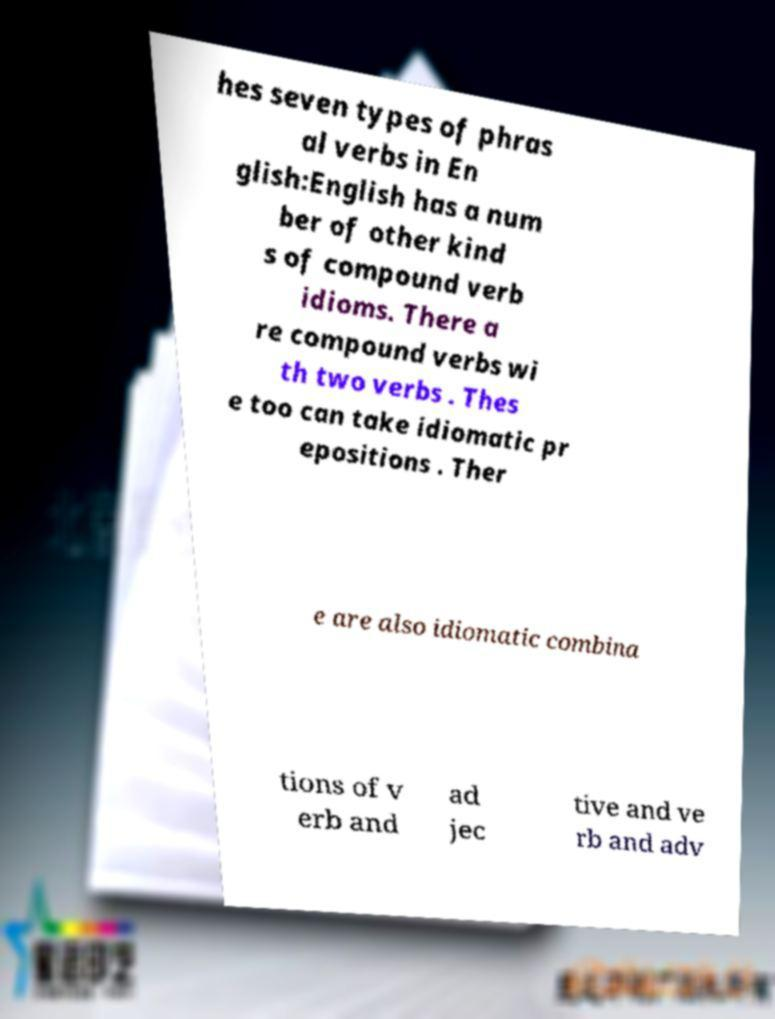Can you accurately transcribe the text from the provided image for me? hes seven types of phras al verbs in En glish:English has a num ber of other kind s of compound verb idioms. There a re compound verbs wi th two verbs . Thes e too can take idiomatic pr epositions . Ther e are also idiomatic combina tions of v erb and ad jec tive and ve rb and adv 